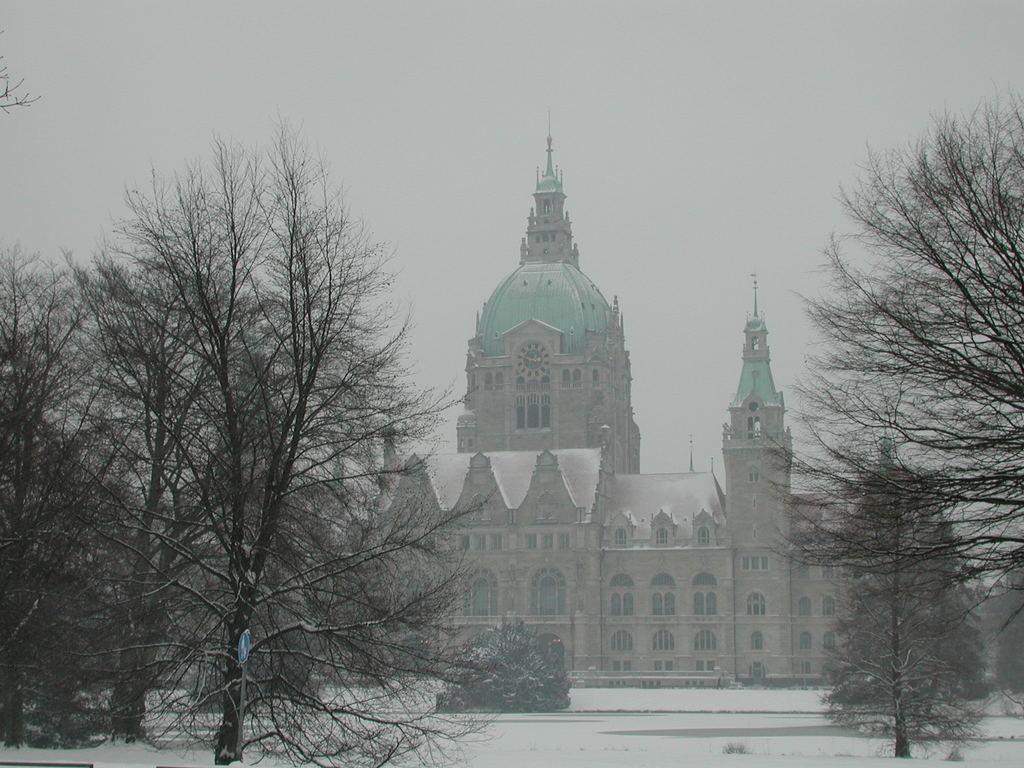In one or two sentences, can you explain what this image depicts? In this image we can see the land covered with snow. There is a building in the middle of the image and trees on the both sides of the image. The sky is in white color. In front of the building, there is a plant. 